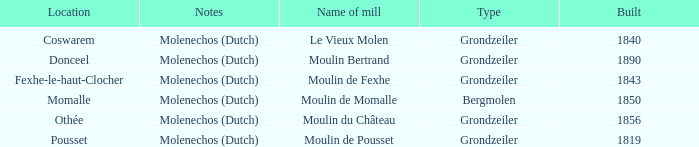What is the Name of the Grondzeiler Mill? Le Vieux Molen, Moulin Bertrand, Moulin de Fexhe, Moulin du Château, Moulin de Pousset. 